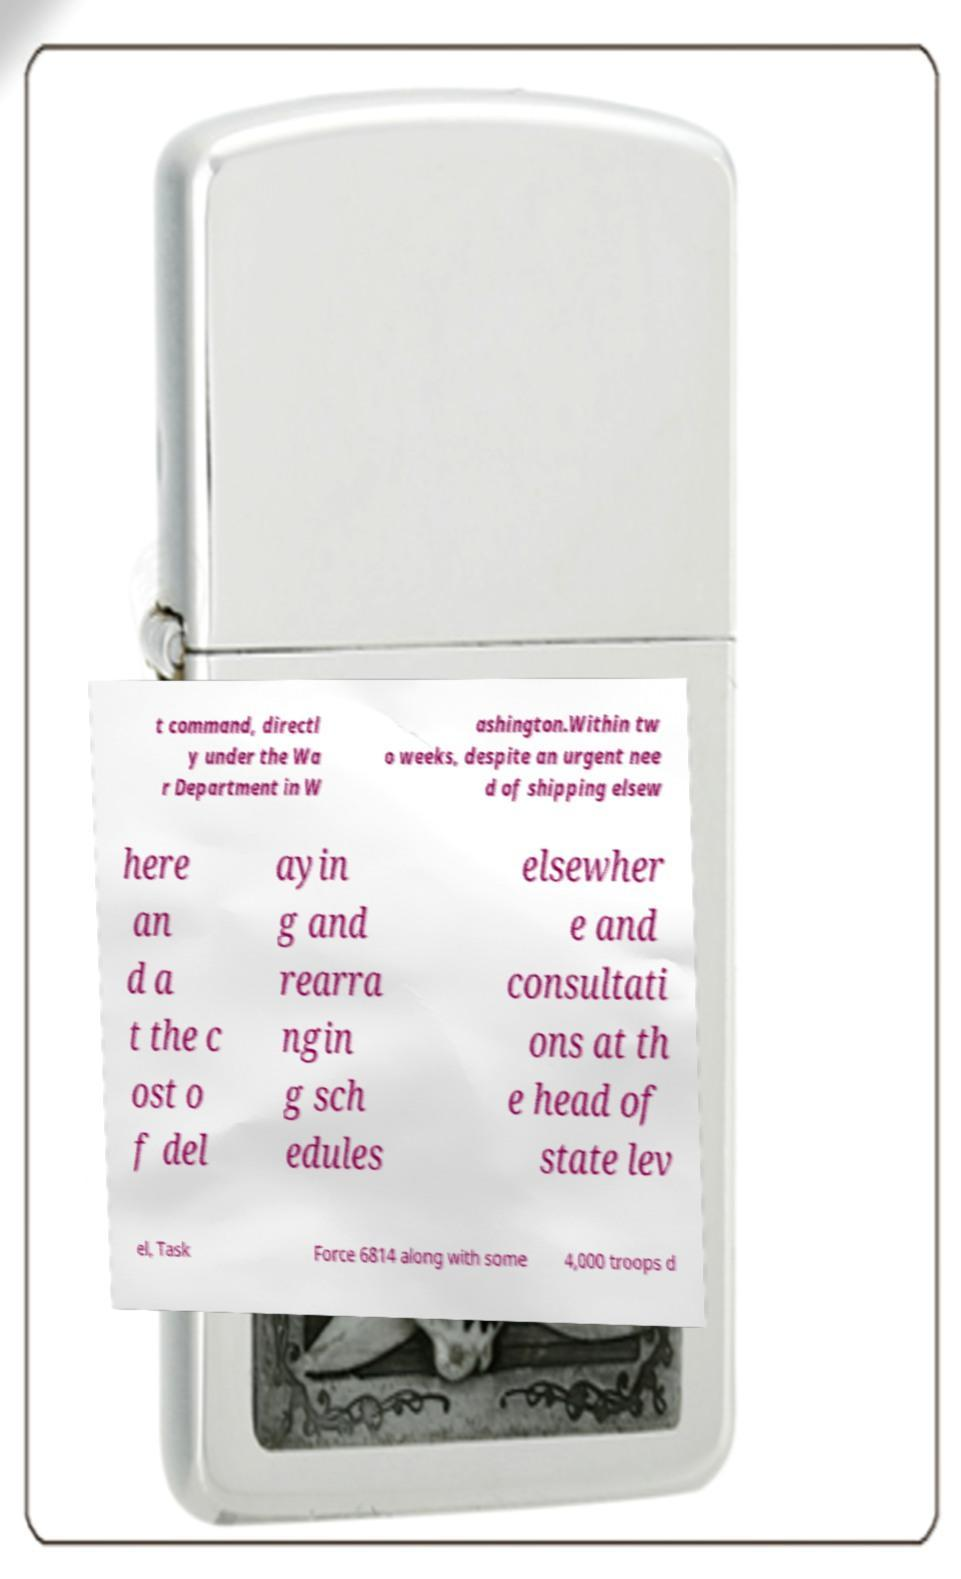Can you read and provide the text displayed in the image?This photo seems to have some interesting text. Can you extract and type it out for me? t command, directl y under the Wa r Department in W ashington.Within tw o weeks, despite an urgent nee d of shipping elsew here an d a t the c ost o f del ayin g and rearra ngin g sch edules elsewher e and consultati ons at th e head of state lev el, Task Force 6814 along with some 4,000 troops d 